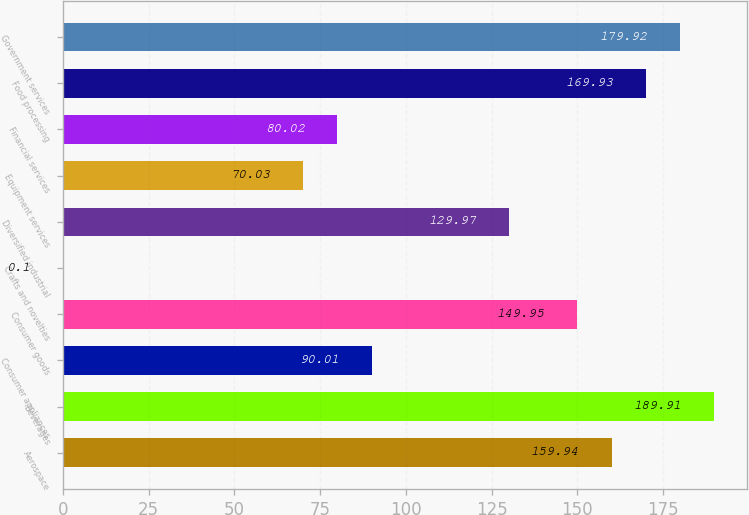<chart> <loc_0><loc_0><loc_500><loc_500><bar_chart><fcel>Aerospace<fcel>Beverages<fcel>Consumer appliances<fcel>Consumer goods<fcel>Crafts and novelties<fcel>Diversified industrial<fcel>Equipment services<fcel>Financial services<fcel>Food processing<fcel>Government services<nl><fcel>159.94<fcel>189.91<fcel>90.01<fcel>149.95<fcel>0.1<fcel>129.97<fcel>70.03<fcel>80.02<fcel>169.93<fcel>179.92<nl></chart> 